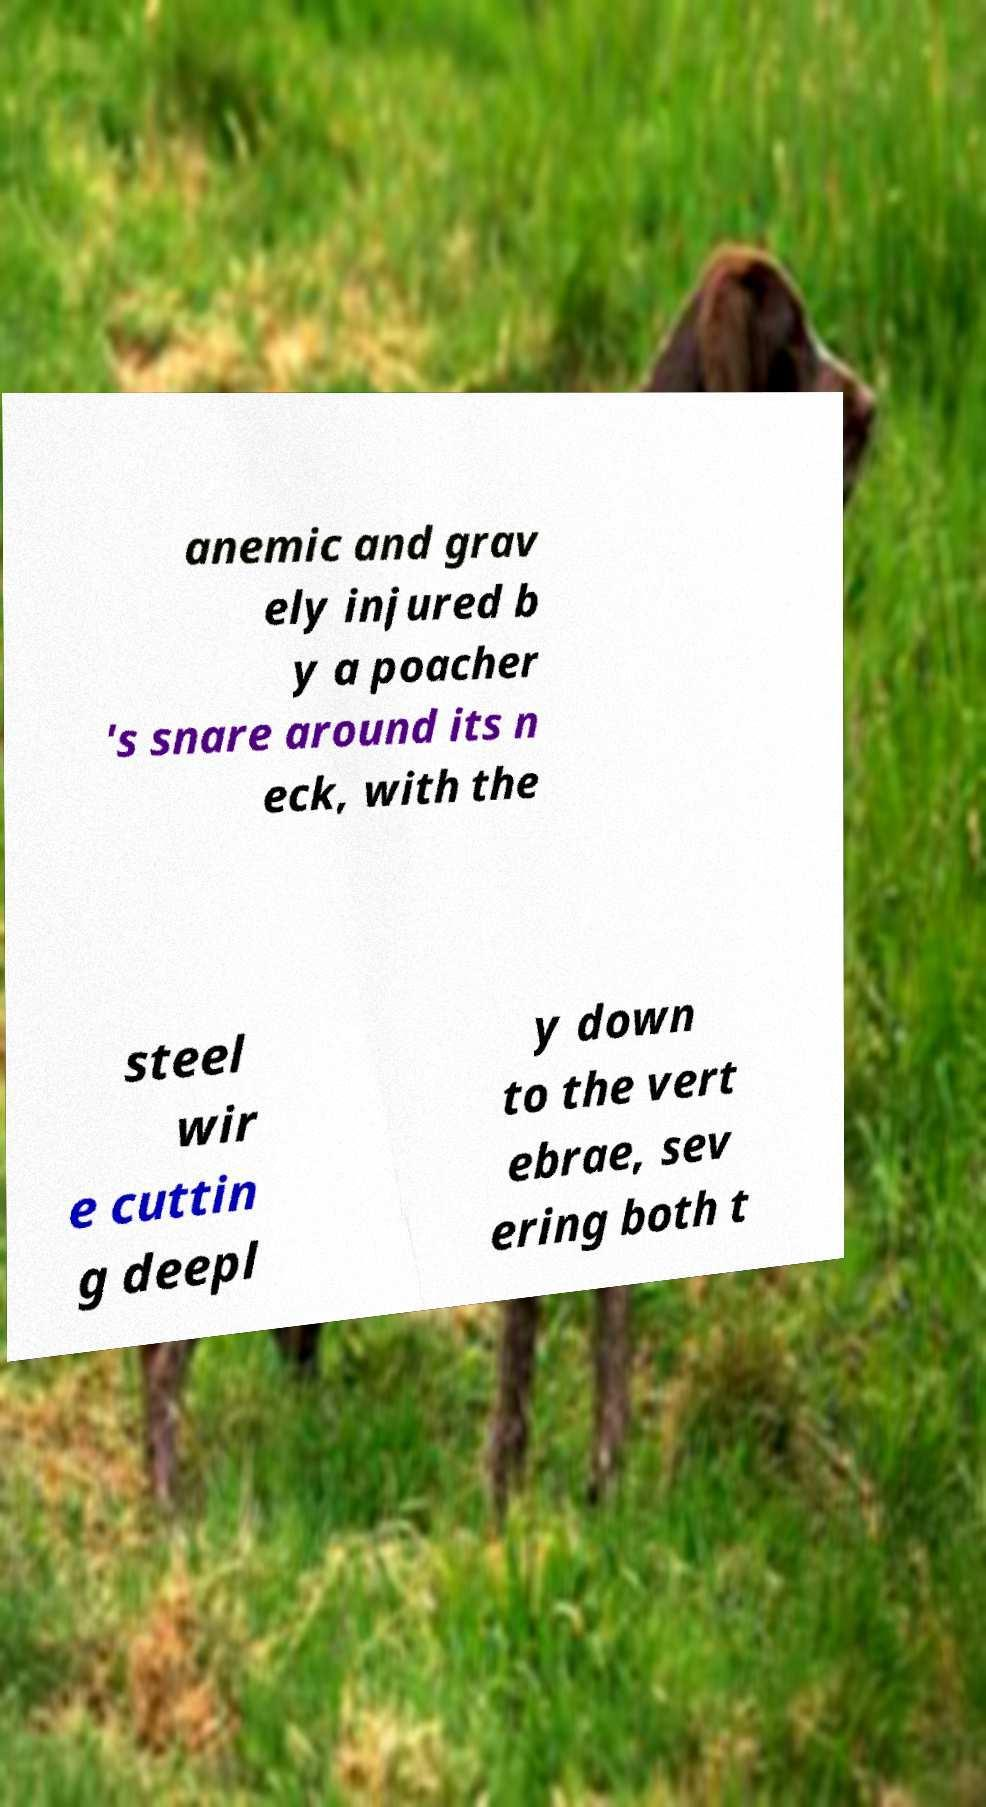Could you assist in decoding the text presented in this image and type it out clearly? anemic and grav ely injured b y a poacher 's snare around its n eck, with the steel wir e cuttin g deepl y down to the vert ebrae, sev ering both t 